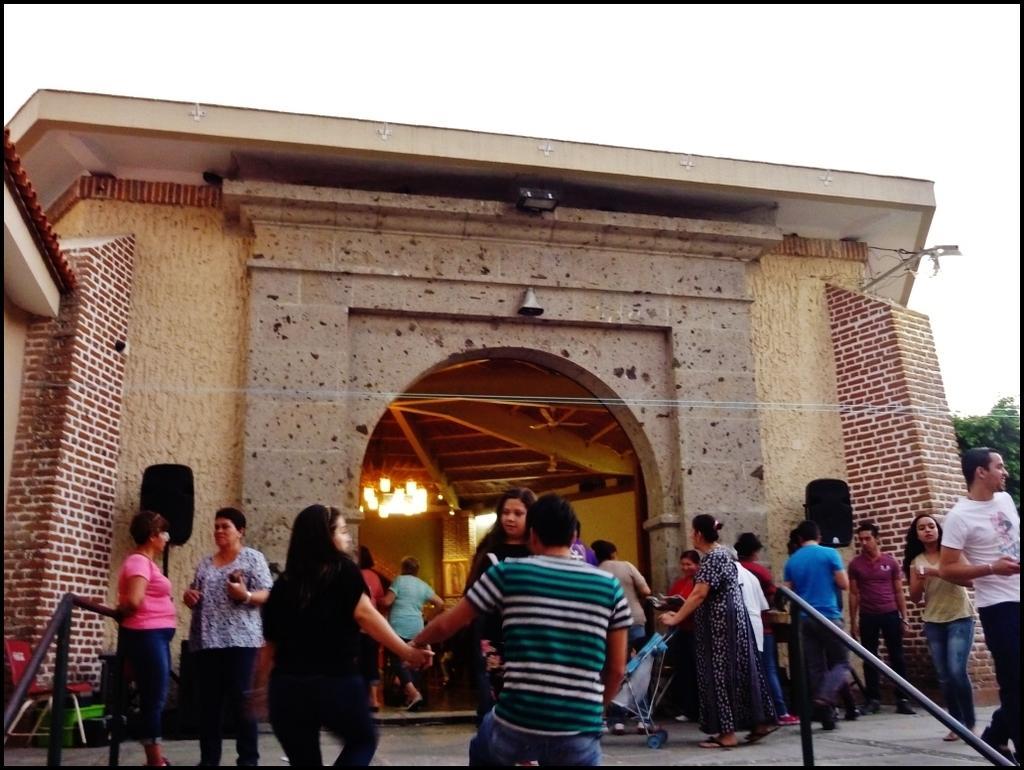Please provide a concise description of this image. This picture might be taken from outside of the building. In this image, we can see few people are walking and few people are standing. In the background, we can see a building and trees. In the building, we can see few lights on the roof. On the top, we can see a sky. 